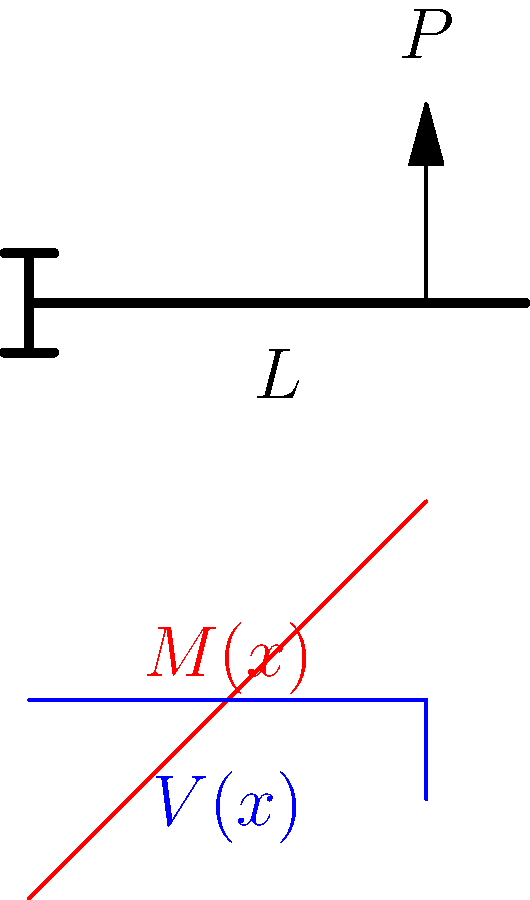In the context of translating ancient Islamic texts on mechanics, consider a cantilever beam of length $L$ with a point load $P$ at its free end. How does the bending moment $M(x)$ vary along the length of the beam, and what is its maximum value? To understand the bending moment distribution in this cantilever beam, let's follow these steps:

1. Establish the coordinate system: 
   Let $x$ be the distance from the fixed end, ranging from 0 to $L$.

2. Determine the reaction forces:
   At the fixed end (x = 0), there will be a reaction force $R = P$ and a reaction moment $M_0 = PL$.

3. Derive the shear force equation:
   The shear force $V(x)$ is constant along the beam and equal to $-P$.

4. Derive the bending moment equation:
   $$ M(x) = M_0 - P(L-x) = PL - P(L-x) = Px $$

5. Analyze the bending moment distribution:
   - At x = 0 (fixed end): $M(0) = 0$
   - At x = L (free end): $M(L) = PL$ (maximum value)

6. Interpret the results:
   The bending moment increases linearly from 0 at the fixed end to a maximum value of $PL$ at the free end where the load is applied.

This analysis demonstrates how ancient scholars might have approached problems of structural mechanics, providing insight into the historical development of engineering principles.
Answer: $M(x) = Px$, with a maximum value of $PL$ at the free end. 